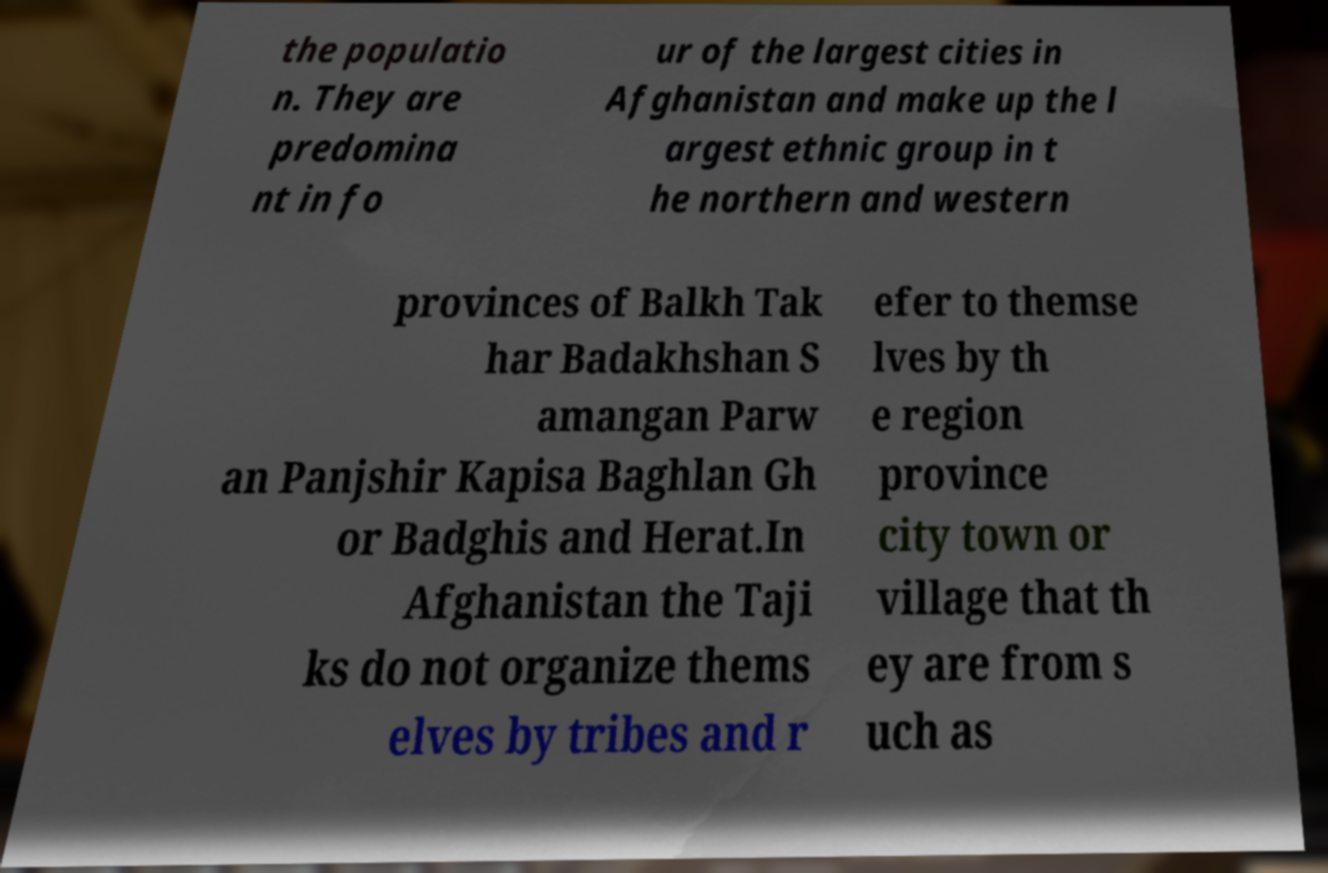Can you read and provide the text displayed in the image?This photo seems to have some interesting text. Can you extract and type it out for me? the populatio n. They are predomina nt in fo ur of the largest cities in Afghanistan and make up the l argest ethnic group in t he northern and western provinces of Balkh Tak har Badakhshan S amangan Parw an Panjshir Kapisa Baghlan Gh or Badghis and Herat.In Afghanistan the Taji ks do not organize thems elves by tribes and r efer to themse lves by th e region province city town or village that th ey are from s uch as 